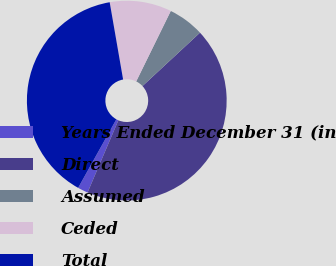Convert chart. <chart><loc_0><loc_0><loc_500><loc_500><pie_chart><fcel>Years Ended December 31 (in<fcel>Direct<fcel>Assumed<fcel>Ceded<fcel>Total<nl><fcel>1.67%<fcel>43.33%<fcel>5.83%<fcel>10.0%<fcel>39.17%<nl></chart> 